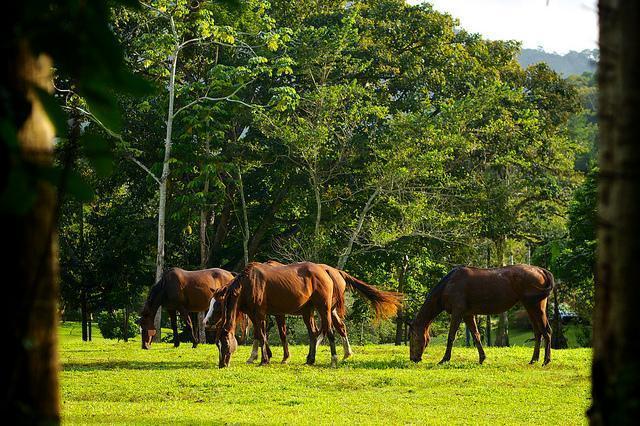How many animals are in this scene?
Give a very brief answer. 3. How many horses are in the field?
Give a very brief answer. 3. How many horses are there?
Give a very brief answer. 3. How many motorcycles are between the sidewalk and the yellow line in the road?
Give a very brief answer. 0. 